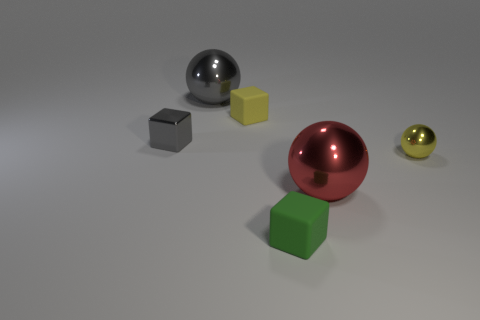There is a small gray thing that is the same material as the red thing; what shape is it?
Give a very brief answer. Cube. How many small gray shiny blocks are to the right of the tiny matte block behind the rubber block that is in front of the tiny shiny ball?
Provide a succinct answer. 0. There is a small object that is both behind the small yellow metal sphere and to the right of the tiny gray thing; what shape is it?
Ensure brevity in your answer.  Cube. Are there fewer yellow balls left of the tiny gray metal cube than small green matte things?
Your response must be concise. Yes. What number of tiny objects are cyan things or green objects?
Give a very brief answer. 1. The gray ball has what size?
Offer a very short reply. Large. There is a tiny green rubber thing; what number of spheres are on the right side of it?
Give a very brief answer. 2. There is a gray metallic thing that is the same shape as the red thing; what is its size?
Offer a terse response. Large. What is the size of the metallic ball that is both to the left of the small metal sphere and in front of the small yellow block?
Ensure brevity in your answer.  Large. Does the small metal sphere have the same color as the tiny matte cube that is behind the gray cube?
Offer a very short reply. Yes. 